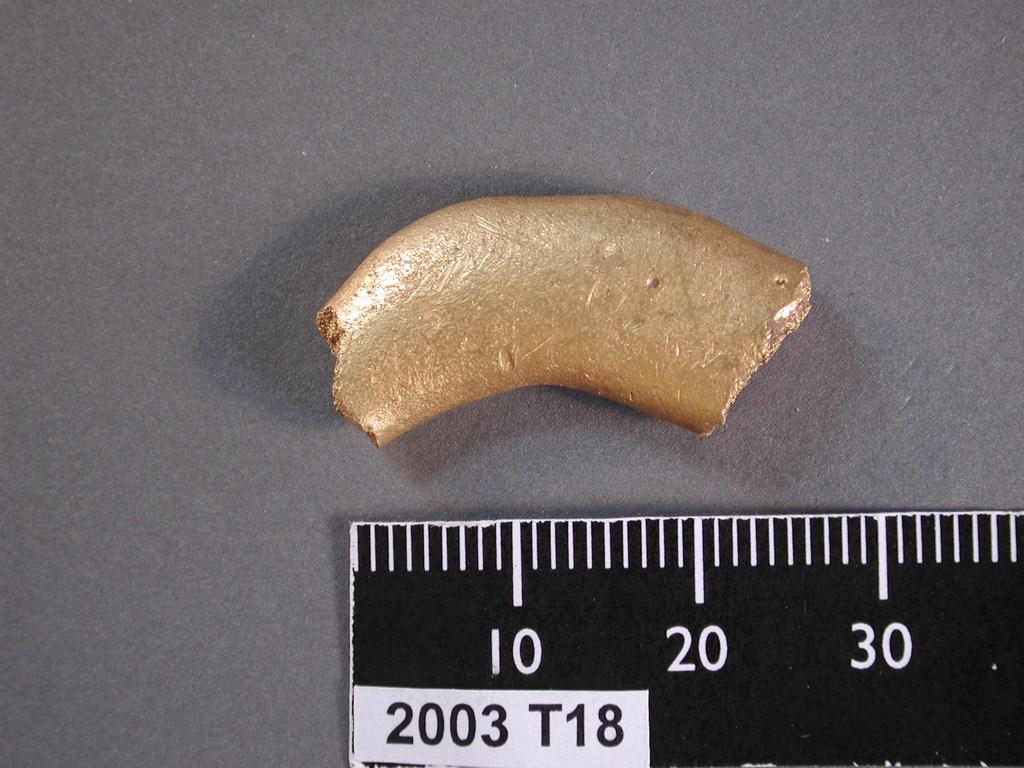Is this item longer than 30 units on this ruler?
Give a very brief answer. No. 